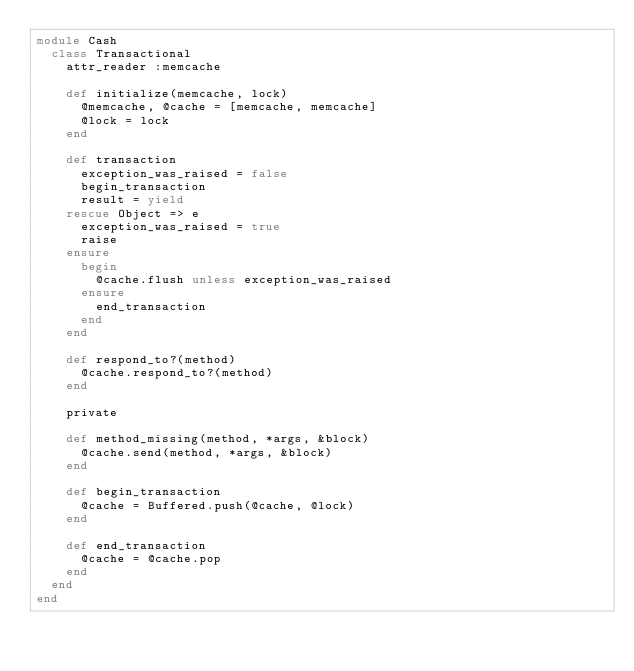<code> <loc_0><loc_0><loc_500><loc_500><_Ruby_>module Cash
  class Transactional
    attr_reader :memcache

    def initialize(memcache, lock)
      @memcache, @cache = [memcache, memcache]
      @lock = lock
    end

    def transaction
      exception_was_raised = false
      begin_transaction
      result = yield
    rescue Object => e
      exception_was_raised = true
      raise
    ensure
      begin
        @cache.flush unless exception_was_raised
      ensure
        end_transaction
      end
    end

    def respond_to?(method)
      @cache.respond_to?(method)
    end

    private

    def method_missing(method, *args, &block)
      @cache.send(method, *args, &block)
    end

    def begin_transaction
      @cache = Buffered.push(@cache, @lock)
    end

    def end_transaction
      @cache = @cache.pop
    end
  end
end
</code> 